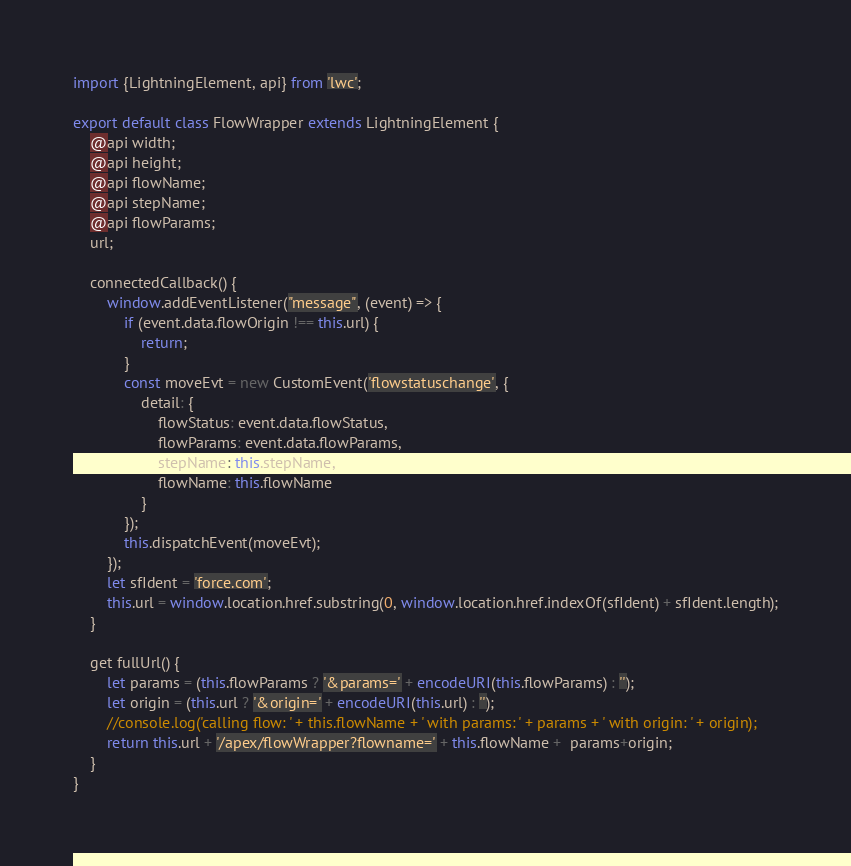Convert code to text. <code><loc_0><loc_0><loc_500><loc_500><_JavaScript_>import {LightningElement, api} from 'lwc';

export default class FlowWrapper extends LightningElement {
    @api width;
    @api height;
    @api flowName;
    @api stepName;
    @api flowParams;
    url;

    connectedCallback() {
        window.addEventListener("message", (event) => {
            if (event.data.flowOrigin !== this.url) {
                return;
            }
            const moveEvt = new CustomEvent('flowstatuschange', {
                detail: {
                    flowStatus: event.data.flowStatus,
                    flowParams: event.data.flowParams,
                    stepName: this.stepName,
                    flowName: this.flowName
                }
            });
            this.dispatchEvent(moveEvt);
        });
        let sfIdent = 'force.com';
        this.url = window.location.href.substring(0, window.location.href.indexOf(sfIdent) + sfIdent.length);
    }

    get fullUrl() {
        let params = (this.flowParams ? '&params=' + encodeURI(this.flowParams) : '');
        let origin = (this.url ? '&origin=' + encodeURI(this.url) : '');
        //console.log('calling flow: ' + this.flowName + ' with params: ' + params + ' with origin: ' + origin);
        return this.url + '/apex/flowWrapper?flowname=' + this.flowName +  params+origin;
    }
}</code> 